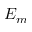Convert formula to latex. <formula><loc_0><loc_0><loc_500><loc_500>E _ { m }</formula> 